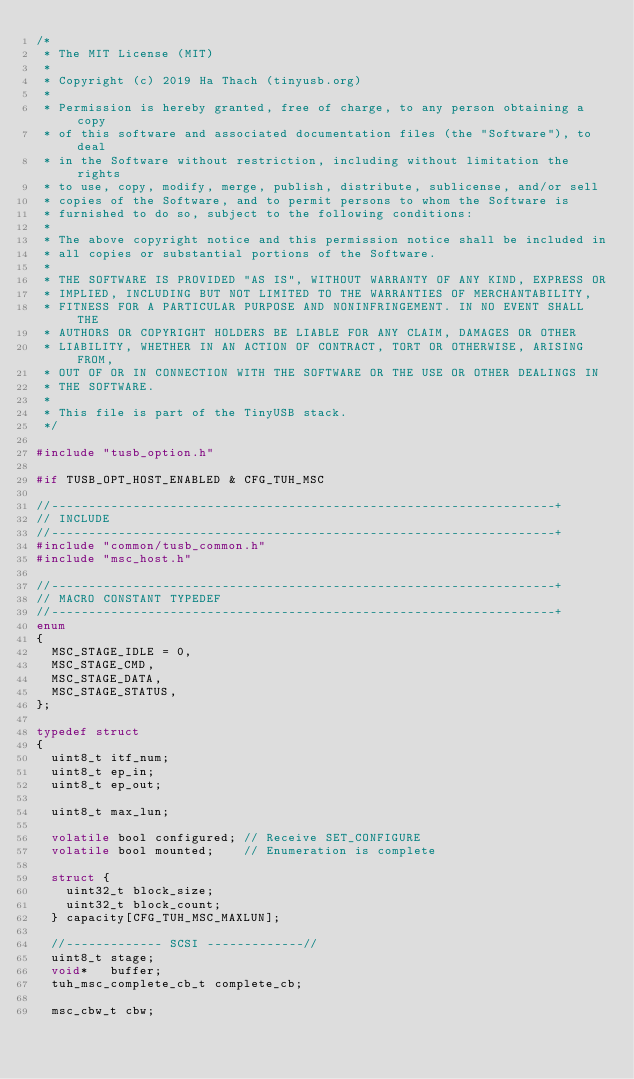<code> <loc_0><loc_0><loc_500><loc_500><_C_>/* 
 * The MIT License (MIT)
 *
 * Copyright (c) 2019 Ha Thach (tinyusb.org)
 *
 * Permission is hereby granted, free of charge, to any person obtaining a copy
 * of this software and associated documentation files (the "Software"), to deal
 * in the Software without restriction, including without limitation the rights
 * to use, copy, modify, merge, publish, distribute, sublicense, and/or sell
 * copies of the Software, and to permit persons to whom the Software is
 * furnished to do so, subject to the following conditions:
 *
 * The above copyright notice and this permission notice shall be included in
 * all copies or substantial portions of the Software.
 *
 * THE SOFTWARE IS PROVIDED "AS IS", WITHOUT WARRANTY OF ANY KIND, EXPRESS OR
 * IMPLIED, INCLUDING BUT NOT LIMITED TO THE WARRANTIES OF MERCHANTABILITY,
 * FITNESS FOR A PARTICULAR PURPOSE AND NONINFRINGEMENT. IN NO EVENT SHALL THE
 * AUTHORS OR COPYRIGHT HOLDERS BE LIABLE FOR ANY CLAIM, DAMAGES OR OTHER
 * LIABILITY, WHETHER IN AN ACTION OF CONTRACT, TORT OR OTHERWISE, ARISING FROM,
 * OUT OF OR IN CONNECTION WITH THE SOFTWARE OR THE USE OR OTHER DEALINGS IN
 * THE SOFTWARE.
 *
 * This file is part of the TinyUSB stack.
 */

#include "tusb_option.h"

#if TUSB_OPT_HOST_ENABLED & CFG_TUH_MSC

//--------------------------------------------------------------------+
// INCLUDE
//--------------------------------------------------------------------+
#include "common/tusb_common.h"
#include "msc_host.h"

//--------------------------------------------------------------------+
// MACRO CONSTANT TYPEDEF
//--------------------------------------------------------------------+
enum
{
  MSC_STAGE_IDLE = 0,
  MSC_STAGE_CMD,
  MSC_STAGE_DATA,
  MSC_STAGE_STATUS,
};

typedef struct
{
  uint8_t itf_num;
  uint8_t ep_in;
  uint8_t ep_out;

  uint8_t max_lun;

  volatile bool configured; // Receive SET_CONFIGURE
  volatile bool mounted;    // Enumeration is complete

  struct {
    uint32_t block_size;
    uint32_t block_count;
  } capacity[CFG_TUH_MSC_MAXLUN];

  //------------- SCSI -------------//
  uint8_t stage;
  void*   buffer;
  tuh_msc_complete_cb_t complete_cb;

  msc_cbw_t cbw;</code> 